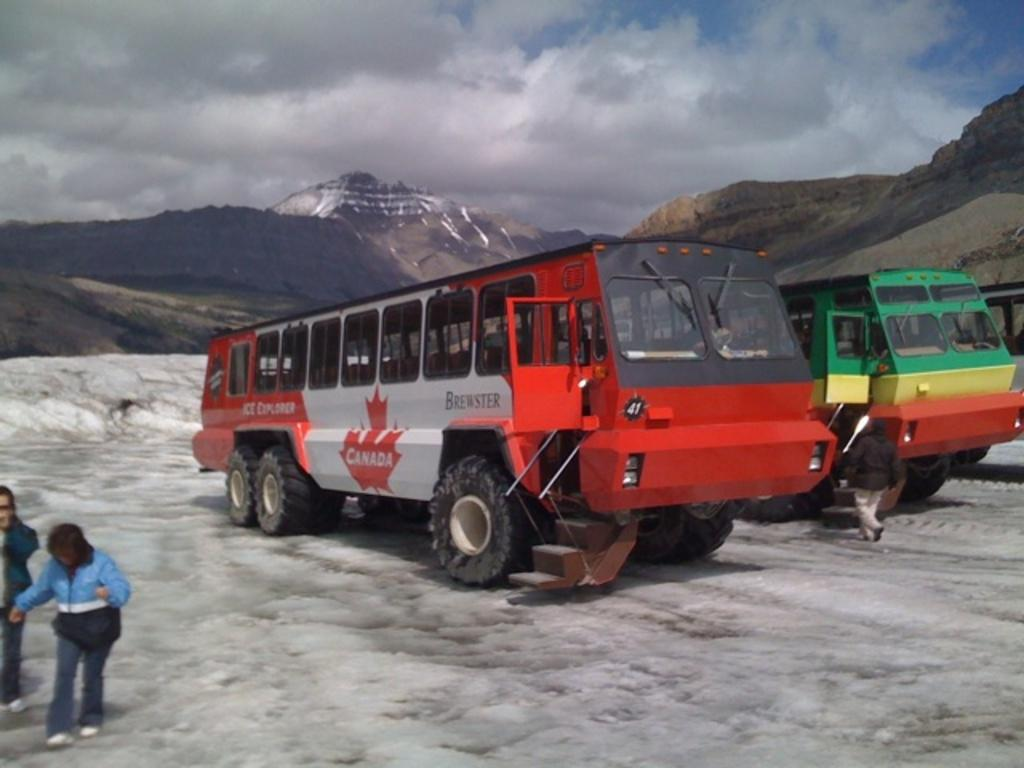How many vehicles can be seen in the image? There are two vehicles in the image. What are the people in the image doing? There are three persons walking in the front of the image. What can be seen in the background of the image? There is a hill in the background of the image. What is visible at the top of the image? The sky is visible at the top of the image. What can be observed about the sky? Clouds are present in the sky. Can you see an airplane flying over the hill in the image? There is no airplane visible in the image. 